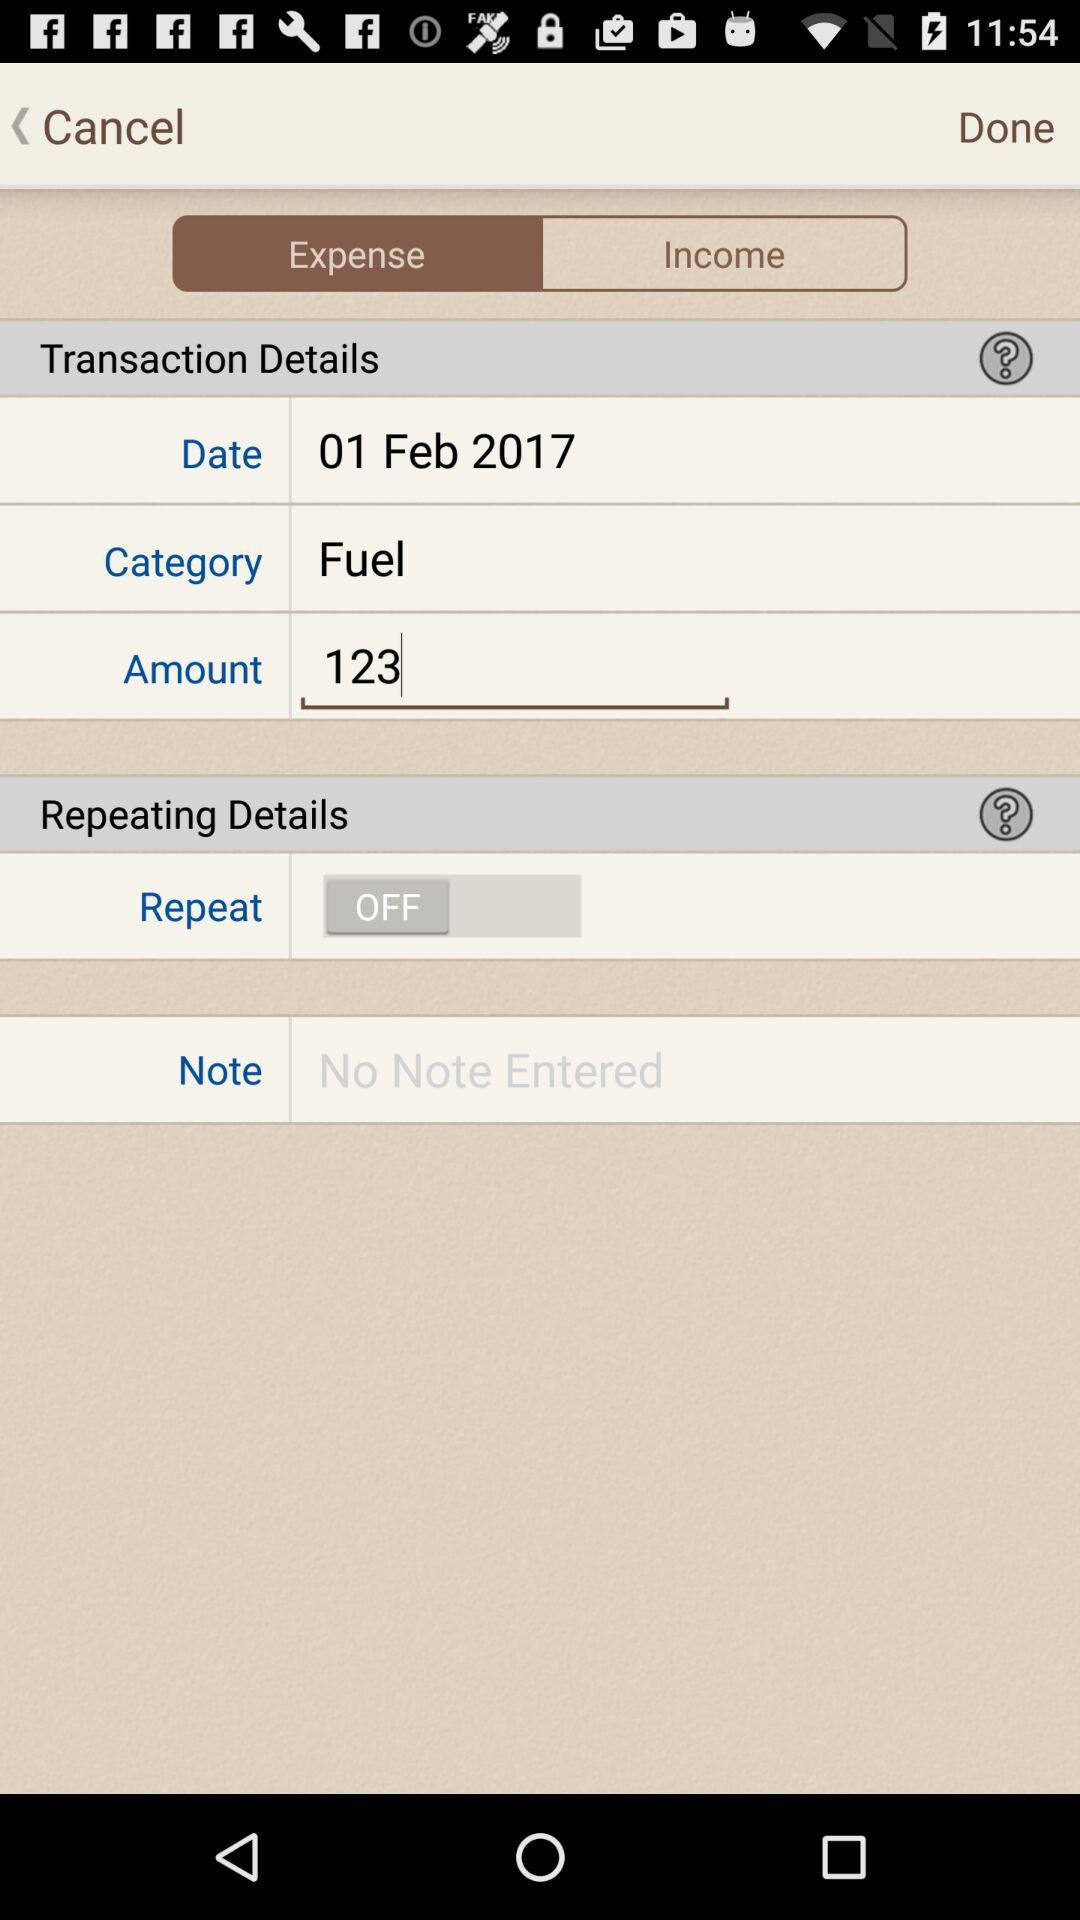What is the selected tab? The selected tab is "Expense". 